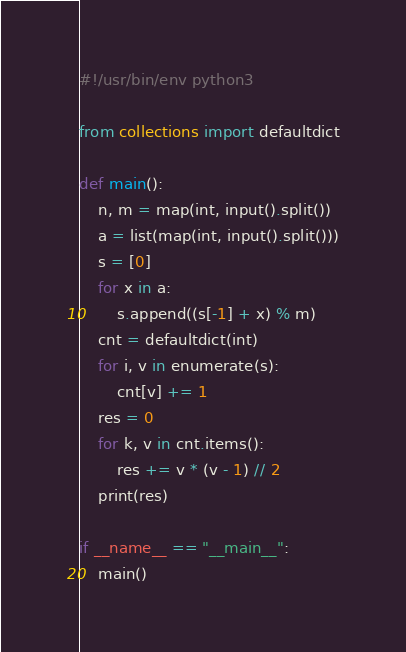Convert code to text. <code><loc_0><loc_0><loc_500><loc_500><_Python_>#!/usr/bin/env python3

from collections import defaultdict

def main():
    n, m = map(int, input().split())
    a = list(map(int, input().split()))
    s = [0]
    for x in a:
        s.append((s[-1] + x) % m)
    cnt = defaultdict(int)
    for i, v in enumerate(s):
        cnt[v] += 1
    res = 0
    for k, v in cnt.items():
        res += v * (v - 1) // 2
    print(res)

if __name__ == "__main__":
    main()
</code> 